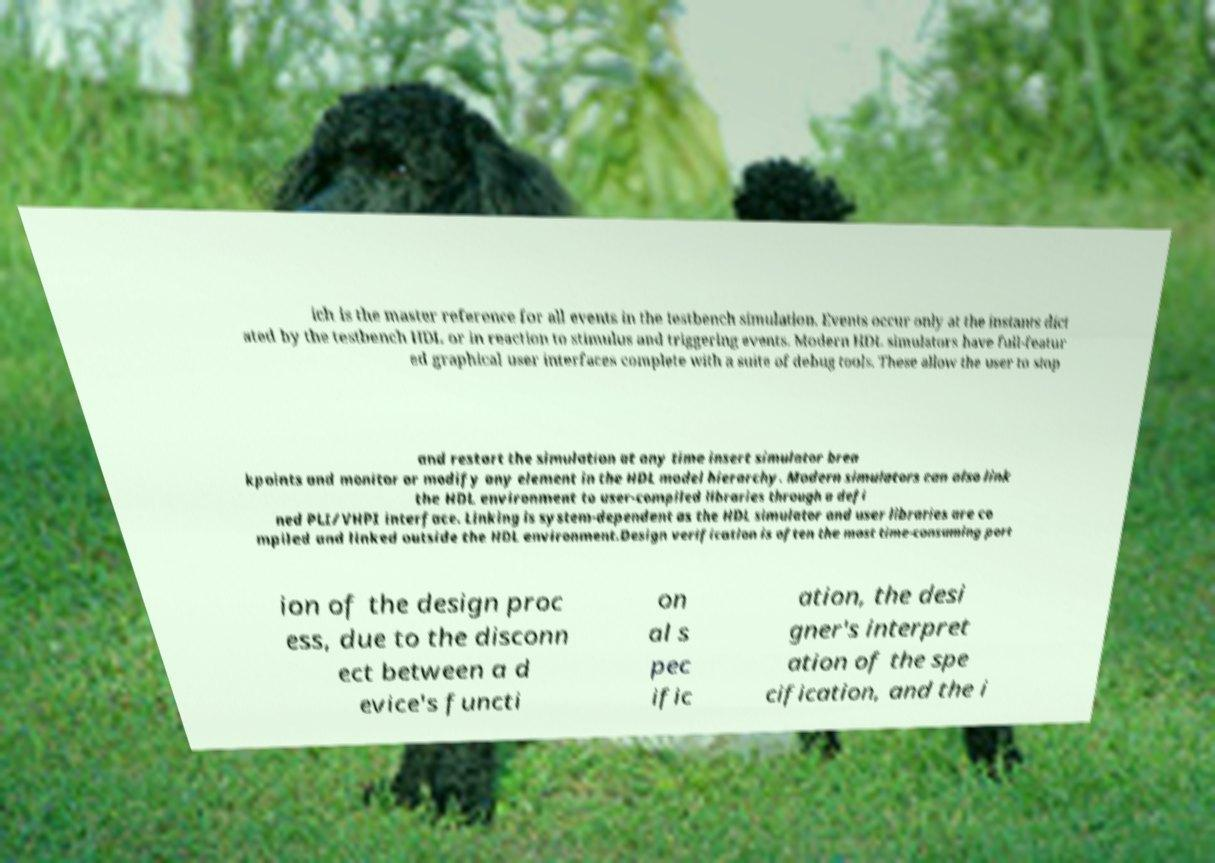Please read and relay the text visible in this image. What does it say? ich is the master reference for all events in the testbench simulation. Events occur only at the instants dict ated by the testbench HDL or in reaction to stimulus and triggering events. Modern HDL simulators have full-featur ed graphical user interfaces complete with a suite of debug tools. These allow the user to stop and restart the simulation at any time insert simulator brea kpoints and monitor or modify any element in the HDL model hierarchy. Modern simulators can also link the HDL environment to user-compiled libraries through a defi ned PLI/VHPI interface. Linking is system-dependent as the HDL simulator and user libraries are co mpiled and linked outside the HDL environment.Design verification is often the most time-consuming port ion of the design proc ess, due to the disconn ect between a d evice's functi on al s pec ific ation, the desi gner's interpret ation of the spe cification, and the i 